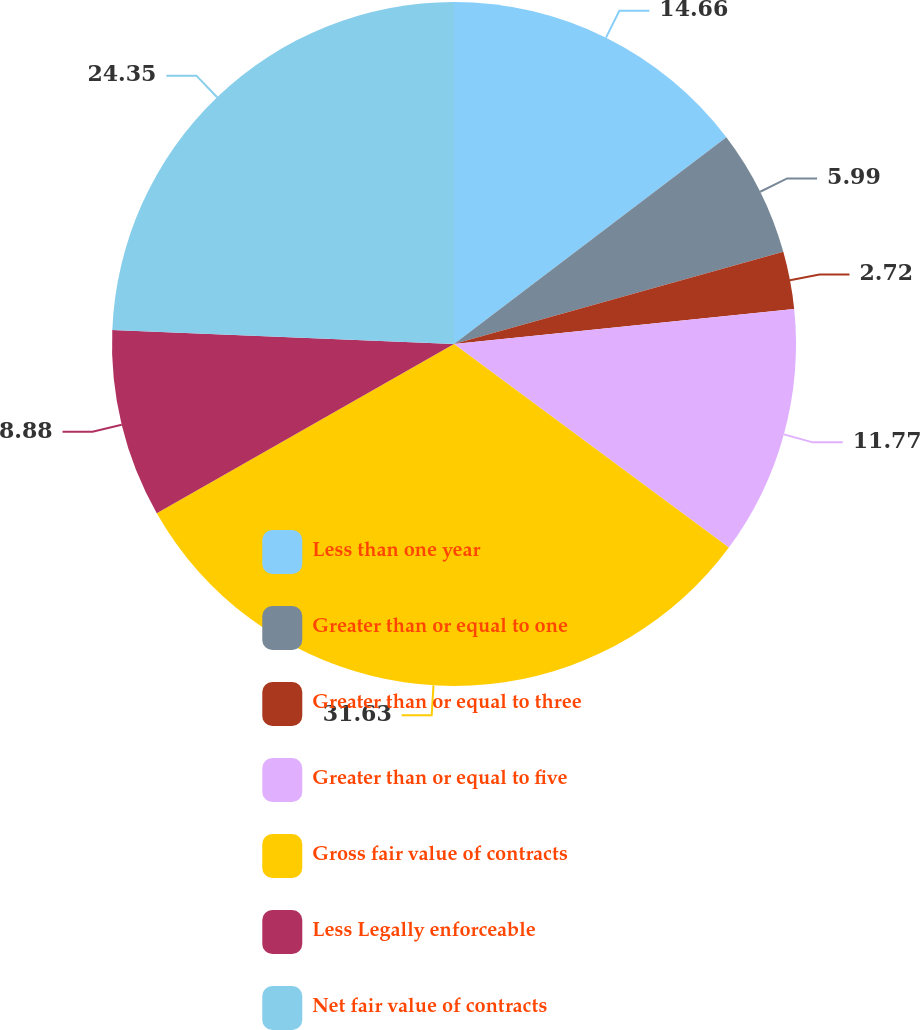Convert chart to OTSL. <chart><loc_0><loc_0><loc_500><loc_500><pie_chart><fcel>Less than one year<fcel>Greater than or equal to one<fcel>Greater than or equal to three<fcel>Greater than or equal to five<fcel>Gross fair value of contracts<fcel>Less Legally enforceable<fcel>Net fair value of contracts<nl><fcel>14.66%<fcel>5.99%<fcel>2.72%<fcel>11.77%<fcel>31.62%<fcel>8.88%<fcel>24.35%<nl></chart> 